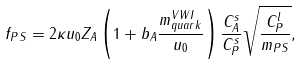Convert formula to latex. <formula><loc_0><loc_0><loc_500><loc_500>f _ { P S } = 2 \kappa u _ { 0 } Z _ { A } \left ( 1 + b _ { A } \frac { m _ { q u a r k } ^ { V W I } } { u _ { 0 } } \right ) \frac { C _ { A } ^ { s } } { C _ { P } ^ { s } } \sqrt { \frac { C _ { P } ^ { l } } { m _ { P S } } } ,</formula> 